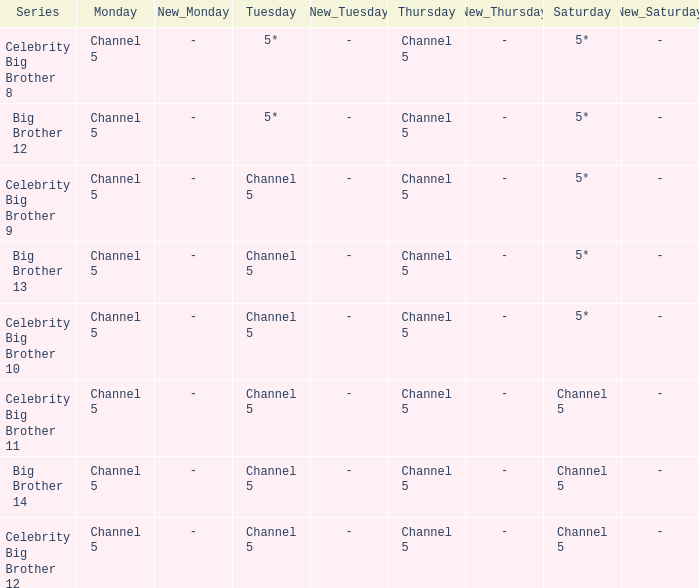Which series airs Saturday on Channel 5? Celebrity Big Brother 11, Big Brother 14, Celebrity Big Brother 12. 